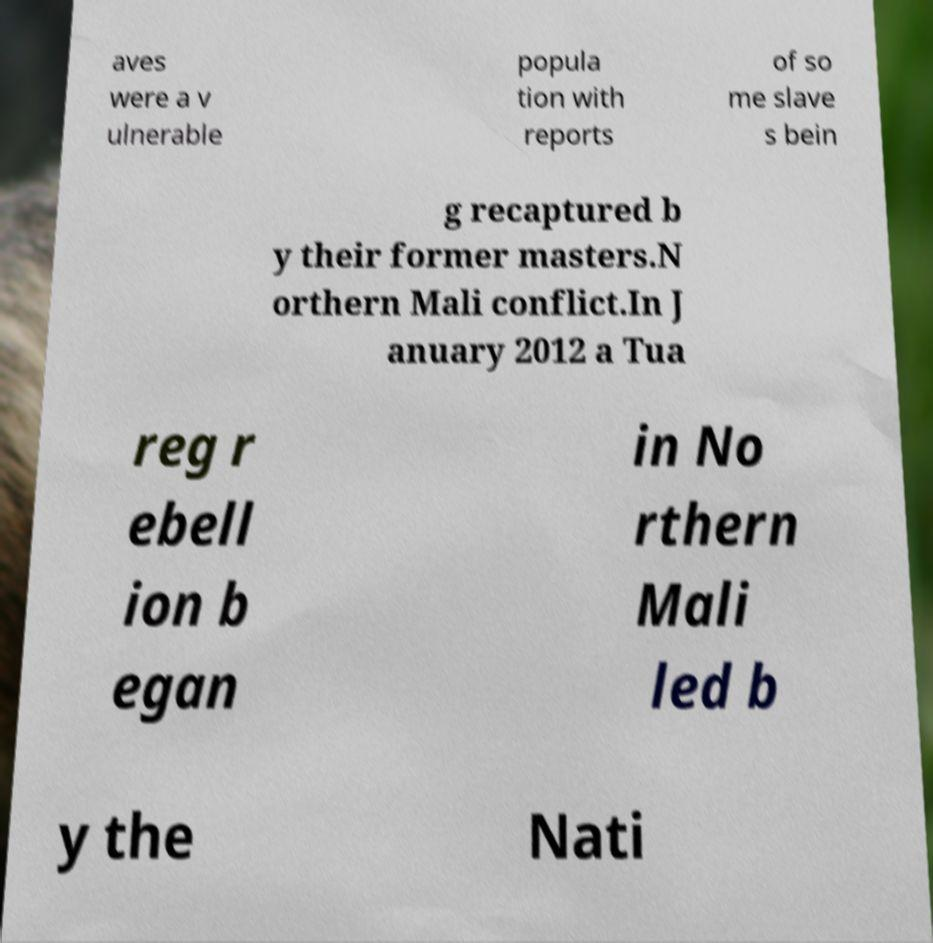For documentation purposes, I need the text within this image transcribed. Could you provide that? aves were a v ulnerable popula tion with reports of so me slave s bein g recaptured b y their former masters.N orthern Mali conflict.In J anuary 2012 a Tua reg r ebell ion b egan in No rthern Mali led b y the Nati 